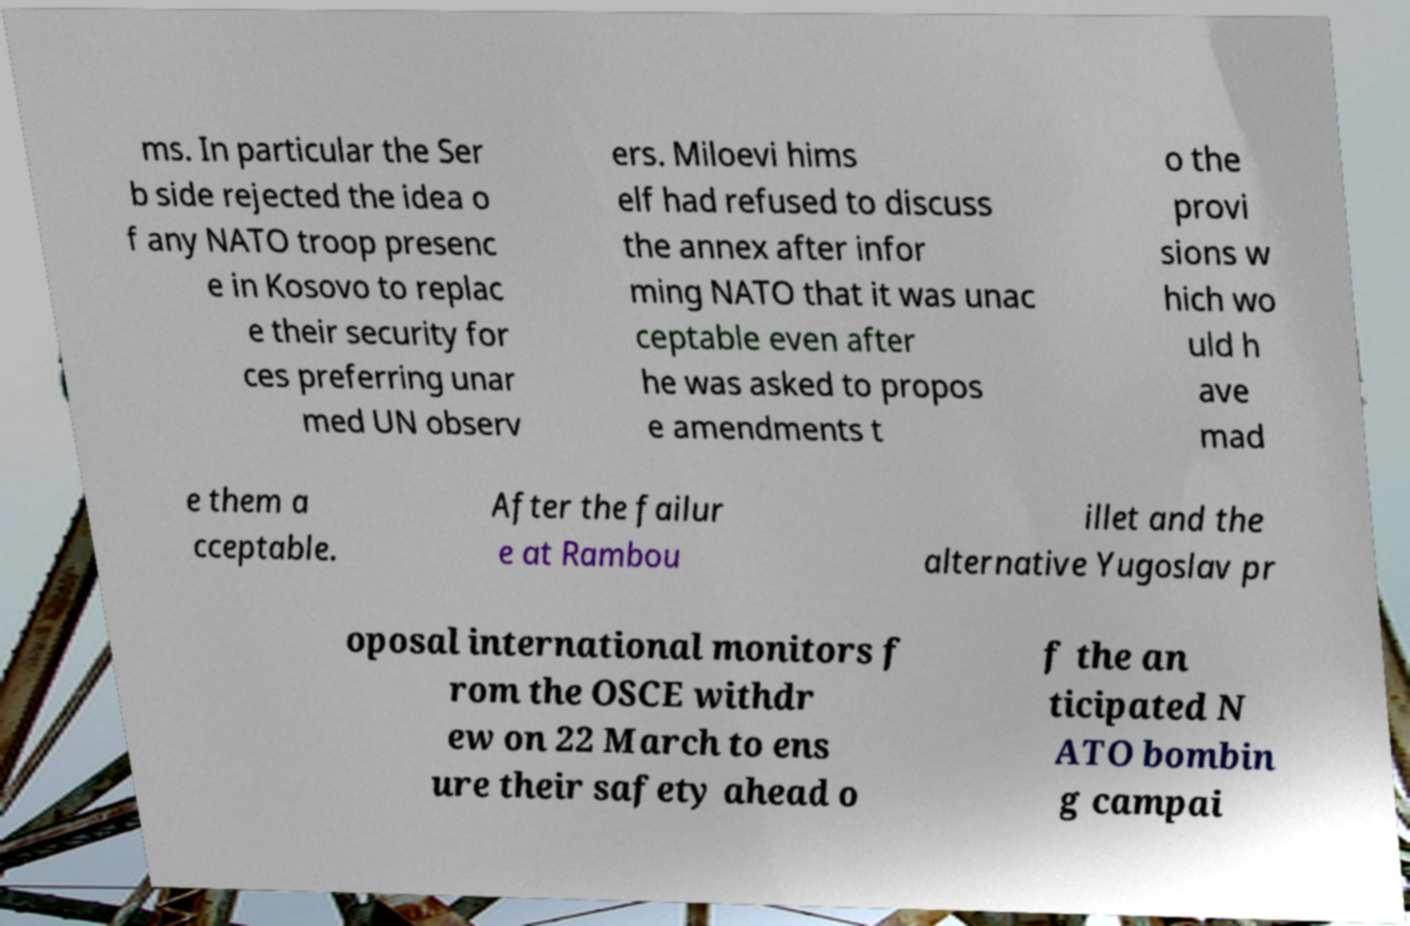Can you accurately transcribe the text from the provided image for me? ms. In particular the Ser b side rejected the idea o f any NATO troop presenc e in Kosovo to replac e their security for ces preferring unar med UN observ ers. Miloevi hims elf had refused to discuss the annex after infor ming NATO that it was unac ceptable even after he was asked to propos e amendments t o the provi sions w hich wo uld h ave mad e them a cceptable. After the failur e at Rambou illet and the alternative Yugoslav pr oposal international monitors f rom the OSCE withdr ew on 22 March to ens ure their safety ahead o f the an ticipated N ATO bombin g campai 